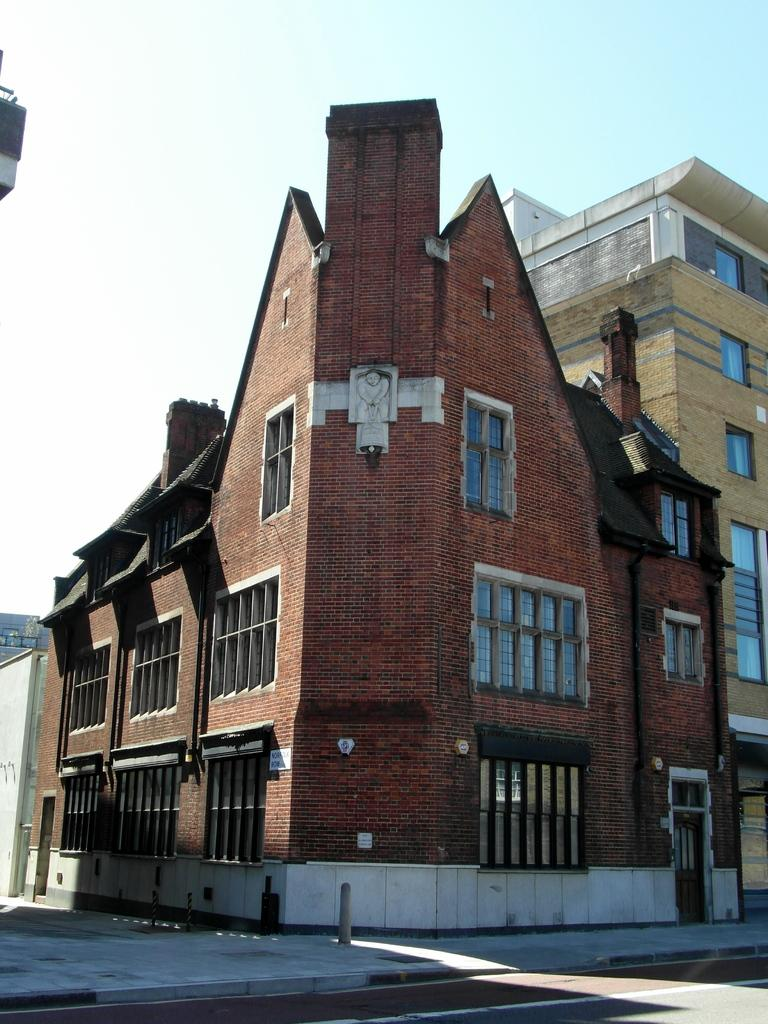What type of view is shown in the image? The image is an outside view. What can be seen at the bottom of the image? There is a road at the bottom of the image. What structures are located in the middle of the image? There are buildings in the middle of the image. What feature do the buildings have? The buildings have windows. What is visible at the top of the image? The sky is visible at the top of the image. What level of belief is depicted in the image? There is no indication of belief in the image; it shows an outside view with a road, buildings, and sky. How many parcels are visible in the image? There are no parcels present in the image. 